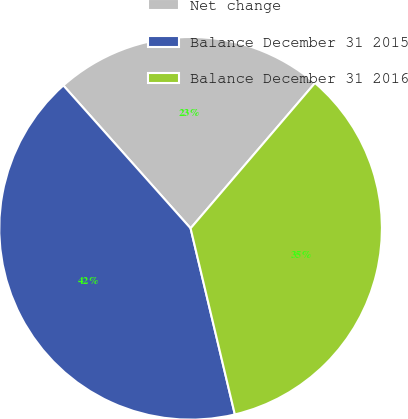Convert chart to OTSL. <chart><loc_0><loc_0><loc_500><loc_500><pie_chart><fcel>Net change<fcel>Balance December 31 2015<fcel>Balance December 31 2016<nl><fcel>22.85%<fcel>42.14%<fcel>35.02%<nl></chart> 